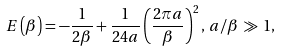Convert formula to latex. <formula><loc_0><loc_0><loc_500><loc_500>E \left ( \beta \right ) = - \frac { 1 } { 2 \beta } + \frac { 1 } { 2 4 a } \left ( \frac { 2 \pi a } { \beta } \right ) ^ { 2 } , \, a / \beta \, \gg \, 1 ,</formula> 